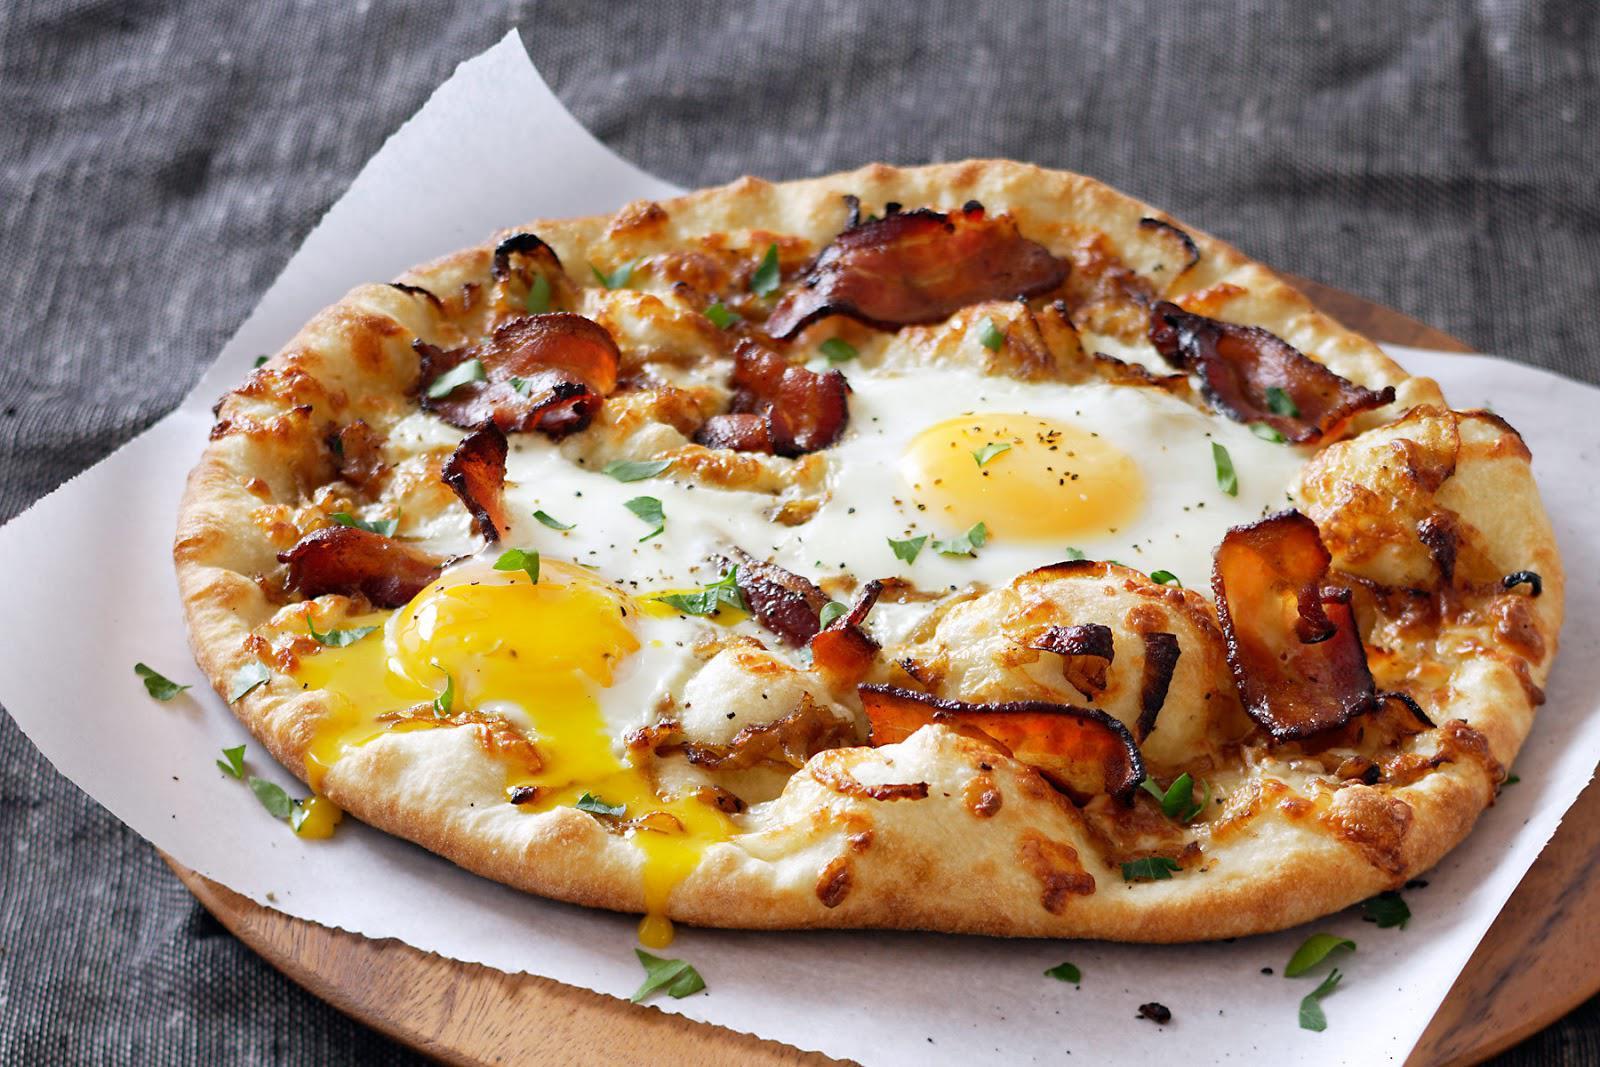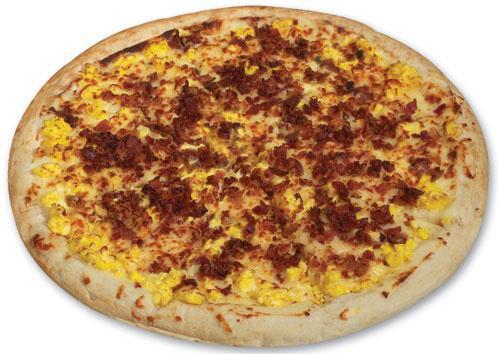The first image is the image on the left, the second image is the image on the right. Evaluate the accuracy of this statement regarding the images: "There is at least one uncut pizza.". Is it true? Answer yes or no. Yes. The first image is the image on the left, the second image is the image on the right. Given the left and right images, does the statement "All the pizzas in these images are still whole circles and have not yet been cut into slices." hold true? Answer yes or no. Yes. 